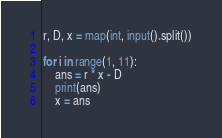<code> <loc_0><loc_0><loc_500><loc_500><_Python_>r, D, x = map(int, input().split())

for i in range(1, 11):
    ans = r * x - D
    print(ans)
    x = ans</code> 